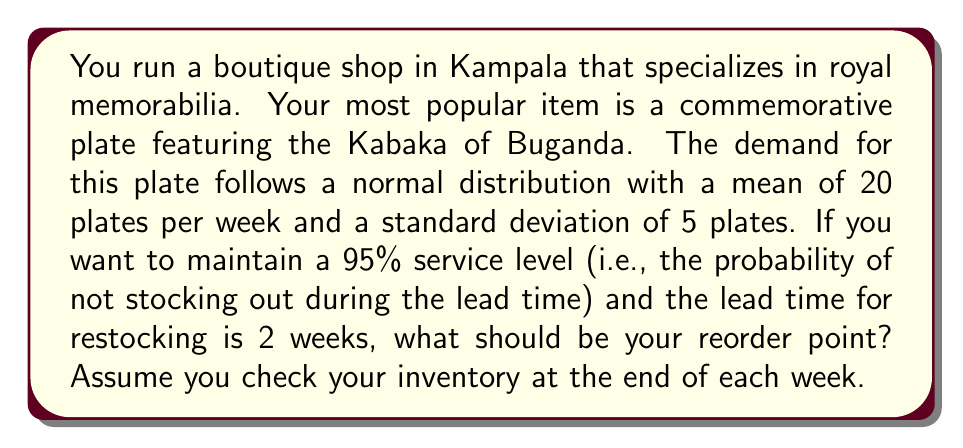Can you solve this math problem? To solve this problem, we'll follow these steps:

1. Calculate the demand during lead time:
   Mean demand during lead time = Weekly mean demand × Lead time
   $\mu_{LT} = 20 \times 2 = 40$ plates

2. Calculate the standard deviation of demand during lead time:
   $\sigma_{LT} = \sigma_{weekly} \times \sqrt{\text{Lead time}}$
   $\sigma_{LT} = 5 \times \sqrt{2} \approx 7.07$ plates

3. Determine the z-score for a 95% service level:
   For a 95% service level, the z-score is approximately 1.645 (from standard normal distribution tables)

4. Calculate the safety stock:
   Safety Stock = z-score × Standard deviation of demand during lead time
   $SS = 1.645 \times 7.07 \approx 11.63$ plates

5. Calculate the reorder point:
   Reorder Point = Mean demand during lead time + Safety Stock
   $ROP = \mu_{LT} + SS = 40 + 11.63 \approx 51.63$ plates

6. Round up to the nearest whole number, as we can't order partial plates.

Therefore, the reorder point should be 52 plates.
Answer: 52 plates 